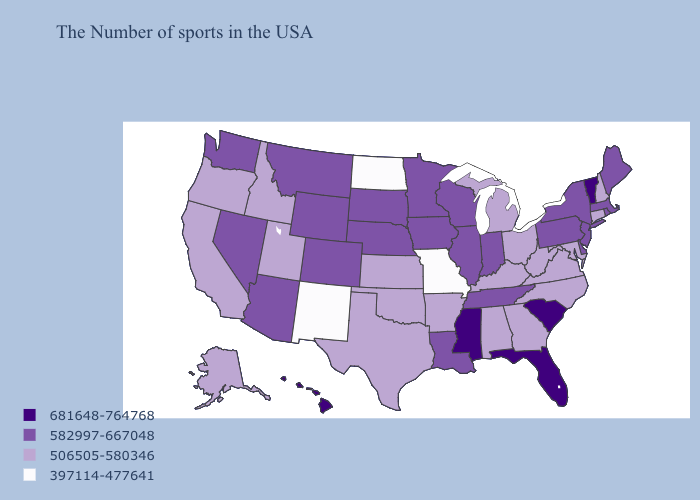What is the highest value in the USA?
Answer briefly. 681648-764768. Name the states that have a value in the range 397114-477641?
Write a very short answer. Missouri, North Dakota, New Mexico. Does Kansas have a lower value than Oregon?
Give a very brief answer. No. Does the map have missing data?
Concise answer only. No. What is the value of Arkansas?
Answer briefly. 506505-580346. Which states have the lowest value in the USA?
Be succinct. Missouri, North Dakota, New Mexico. Is the legend a continuous bar?
Short answer required. No. What is the highest value in the USA?
Write a very short answer. 681648-764768. What is the highest value in the USA?
Quick response, please. 681648-764768. Name the states that have a value in the range 582997-667048?
Short answer required. Maine, Massachusetts, Rhode Island, New York, New Jersey, Delaware, Pennsylvania, Indiana, Tennessee, Wisconsin, Illinois, Louisiana, Minnesota, Iowa, Nebraska, South Dakota, Wyoming, Colorado, Montana, Arizona, Nevada, Washington. Does Rhode Island have the highest value in the Northeast?
Write a very short answer. No. Which states hav the highest value in the South?
Give a very brief answer. South Carolina, Florida, Mississippi. Does Massachusetts have a lower value than Illinois?
Concise answer only. No. Which states have the lowest value in the MidWest?
Concise answer only. Missouri, North Dakota. What is the value of West Virginia?
Keep it brief. 506505-580346. 